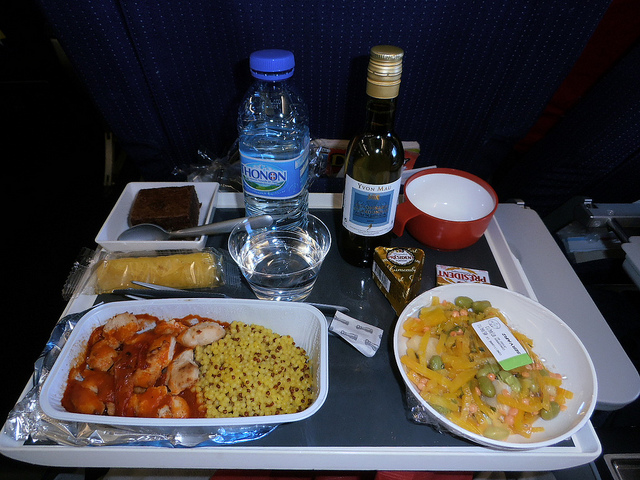Read all the text in this image. HONON PRESIDENT 